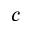Convert formula to latex. <formula><loc_0><loc_0><loc_500><loc_500>c</formula> 